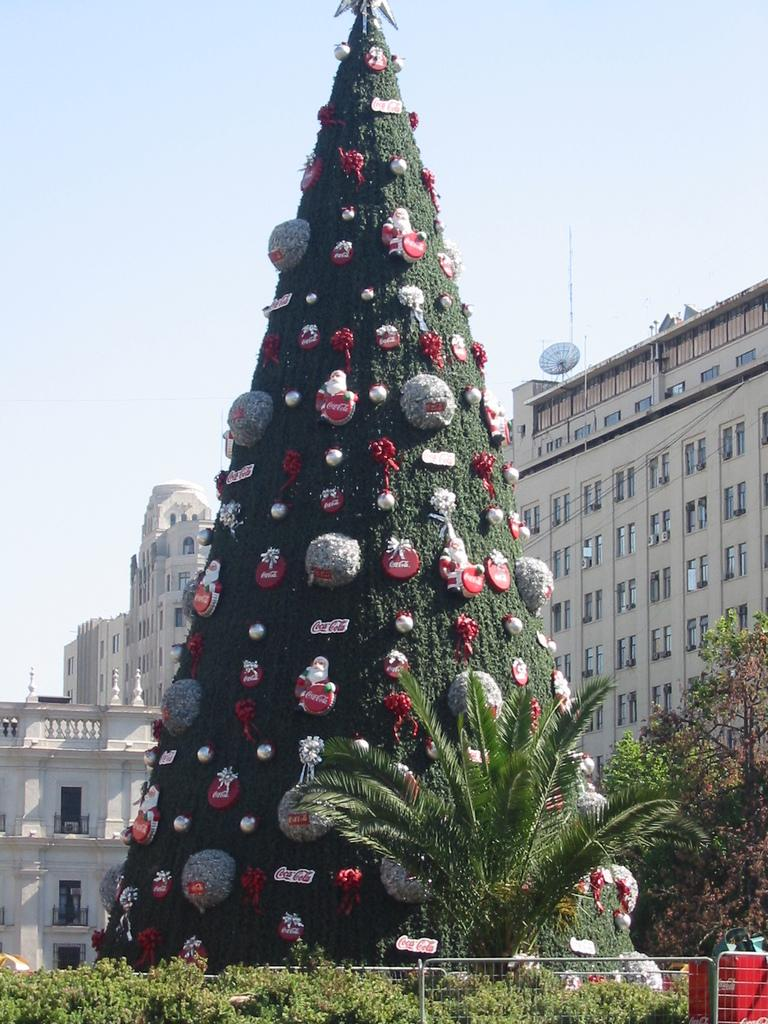What types of vegetation can be seen in the foreground of the image? There are plants and trees in the foreground of the image. What is the main feature in the image? There is a huge Christmas tree in the image. What else can be seen behind the Christmas tree? There are other buildings visible behind the Christmas tree. How many zebras are present near the Christmas tree in the image? There are no zebras present in the image. What type of minister can be seen giving a speech near the Christmas tree? There is no minister or speech present in the image. 